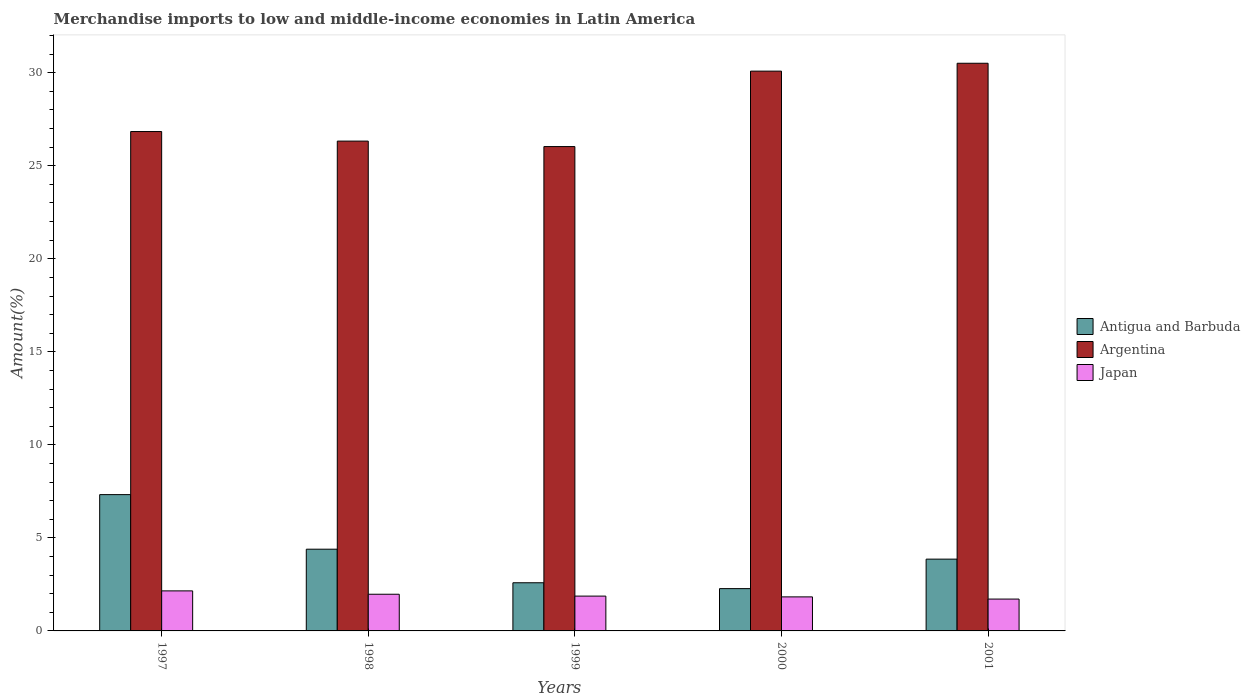How many different coloured bars are there?
Your answer should be very brief. 3. Are the number of bars per tick equal to the number of legend labels?
Offer a terse response. Yes. Are the number of bars on each tick of the X-axis equal?
Give a very brief answer. Yes. How many bars are there on the 3rd tick from the left?
Give a very brief answer. 3. How many bars are there on the 2nd tick from the right?
Provide a short and direct response. 3. What is the label of the 4th group of bars from the left?
Offer a terse response. 2000. What is the percentage of amount earned from merchandise imports in Argentina in 1997?
Provide a succinct answer. 26.84. Across all years, what is the maximum percentage of amount earned from merchandise imports in Argentina?
Offer a very short reply. 30.51. Across all years, what is the minimum percentage of amount earned from merchandise imports in Argentina?
Provide a succinct answer. 26.03. In which year was the percentage of amount earned from merchandise imports in Antigua and Barbuda maximum?
Make the answer very short. 1997. What is the total percentage of amount earned from merchandise imports in Antigua and Barbuda in the graph?
Your answer should be compact. 20.44. What is the difference between the percentage of amount earned from merchandise imports in Antigua and Barbuda in 1997 and that in 2000?
Provide a succinct answer. 5.05. What is the difference between the percentage of amount earned from merchandise imports in Argentina in 1998 and the percentage of amount earned from merchandise imports in Antigua and Barbuda in 1997?
Offer a very short reply. 19. What is the average percentage of amount earned from merchandise imports in Argentina per year?
Keep it short and to the point. 27.96. In the year 1998, what is the difference between the percentage of amount earned from merchandise imports in Argentina and percentage of amount earned from merchandise imports in Japan?
Give a very brief answer. 24.35. What is the ratio of the percentage of amount earned from merchandise imports in Antigua and Barbuda in 1999 to that in 2000?
Ensure brevity in your answer.  1.14. What is the difference between the highest and the second highest percentage of amount earned from merchandise imports in Antigua and Barbuda?
Ensure brevity in your answer.  2.93. What is the difference between the highest and the lowest percentage of amount earned from merchandise imports in Japan?
Provide a succinct answer. 0.44. In how many years, is the percentage of amount earned from merchandise imports in Antigua and Barbuda greater than the average percentage of amount earned from merchandise imports in Antigua and Barbuda taken over all years?
Offer a very short reply. 2. What does the 1st bar from the left in 1999 represents?
Offer a very short reply. Antigua and Barbuda. Is it the case that in every year, the sum of the percentage of amount earned from merchandise imports in Argentina and percentage of amount earned from merchandise imports in Antigua and Barbuda is greater than the percentage of amount earned from merchandise imports in Japan?
Your response must be concise. Yes. Are the values on the major ticks of Y-axis written in scientific E-notation?
Offer a terse response. No. Does the graph contain any zero values?
Your response must be concise. No. What is the title of the graph?
Offer a terse response. Merchandise imports to low and middle-income economies in Latin America. What is the label or title of the Y-axis?
Make the answer very short. Amount(%). What is the Amount(%) in Antigua and Barbuda in 1997?
Offer a terse response. 7.33. What is the Amount(%) of Argentina in 1997?
Your answer should be compact. 26.84. What is the Amount(%) of Japan in 1997?
Offer a very short reply. 2.15. What is the Amount(%) in Antigua and Barbuda in 1998?
Keep it short and to the point. 4.39. What is the Amount(%) in Argentina in 1998?
Keep it short and to the point. 26.32. What is the Amount(%) in Japan in 1998?
Offer a terse response. 1.97. What is the Amount(%) in Antigua and Barbuda in 1999?
Give a very brief answer. 2.59. What is the Amount(%) of Argentina in 1999?
Ensure brevity in your answer.  26.03. What is the Amount(%) of Japan in 1999?
Make the answer very short. 1.87. What is the Amount(%) in Antigua and Barbuda in 2000?
Ensure brevity in your answer.  2.27. What is the Amount(%) in Argentina in 2000?
Offer a very short reply. 30.09. What is the Amount(%) of Japan in 2000?
Give a very brief answer. 1.83. What is the Amount(%) in Antigua and Barbuda in 2001?
Provide a succinct answer. 3.86. What is the Amount(%) in Argentina in 2001?
Ensure brevity in your answer.  30.51. What is the Amount(%) of Japan in 2001?
Your answer should be compact. 1.71. Across all years, what is the maximum Amount(%) of Antigua and Barbuda?
Your response must be concise. 7.33. Across all years, what is the maximum Amount(%) in Argentina?
Your response must be concise. 30.51. Across all years, what is the maximum Amount(%) in Japan?
Make the answer very short. 2.15. Across all years, what is the minimum Amount(%) of Antigua and Barbuda?
Ensure brevity in your answer.  2.27. Across all years, what is the minimum Amount(%) of Argentina?
Provide a succinct answer. 26.03. Across all years, what is the minimum Amount(%) of Japan?
Keep it short and to the point. 1.71. What is the total Amount(%) of Antigua and Barbuda in the graph?
Make the answer very short. 20.44. What is the total Amount(%) in Argentina in the graph?
Make the answer very short. 139.79. What is the total Amount(%) of Japan in the graph?
Offer a terse response. 9.54. What is the difference between the Amount(%) in Antigua and Barbuda in 1997 and that in 1998?
Your response must be concise. 2.93. What is the difference between the Amount(%) of Argentina in 1997 and that in 1998?
Offer a terse response. 0.51. What is the difference between the Amount(%) of Japan in 1997 and that in 1998?
Provide a short and direct response. 0.18. What is the difference between the Amount(%) of Antigua and Barbuda in 1997 and that in 1999?
Provide a short and direct response. 4.74. What is the difference between the Amount(%) of Argentina in 1997 and that in 1999?
Make the answer very short. 0.81. What is the difference between the Amount(%) in Japan in 1997 and that in 1999?
Provide a short and direct response. 0.28. What is the difference between the Amount(%) in Antigua and Barbuda in 1997 and that in 2000?
Provide a succinct answer. 5.05. What is the difference between the Amount(%) of Argentina in 1997 and that in 2000?
Ensure brevity in your answer.  -3.25. What is the difference between the Amount(%) of Japan in 1997 and that in 2000?
Provide a short and direct response. 0.32. What is the difference between the Amount(%) of Antigua and Barbuda in 1997 and that in 2001?
Your answer should be very brief. 3.47. What is the difference between the Amount(%) of Argentina in 1997 and that in 2001?
Your answer should be very brief. -3.67. What is the difference between the Amount(%) of Japan in 1997 and that in 2001?
Make the answer very short. 0.44. What is the difference between the Amount(%) in Antigua and Barbuda in 1998 and that in 1999?
Your answer should be very brief. 1.8. What is the difference between the Amount(%) of Argentina in 1998 and that in 1999?
Provide a succinct answer. 0.29. What is the difference between the Amount(%) in Japan in 1998 and that in 1999?
Offer a terse response. 0.1. What is the difference between the Amount(%) of Antigua and Barbuda in 1998 and that in 2000?
Make the answer very short. 2.12. What is the difference between the Amount(%) in Argentina in 1998 and that in 2000?
Your answer should be very brief. -3.76. What is the difference between the Amount(%) of Japan in 1998 and that in 2000?
Ensure brevity in your answer.  0.14. What is the difference between the Amount(%) of Antigua and Barbuda in 1998 and that in 2001?
Give a very brief answer. 0.53. What is the difference between the Amount(%) in Argentina in 1998 and that in 2001?
Your answer should be very brief. -4.18. What is the difference between the Amount(%) in Japan in 1998 and that in 2001?
Your answer should be very brief. 0.26. What is the difference between the Amount(%) in Antigua and Barbuda in 1999 and that in 2000?
Your answer should be very brief. 0.32. What is the difference between the Amount(%) of Argentina in 1999 and that in 2000?
Offer a very short reply. -4.05. What is the difference between the Amount(%) of Japan in 1999 and that in 2000?
Keep it short and to the point. 0.04. What is the difference between the Amount(%) of Antigua and Barbuda in 1999 and that in 2001?
Keep it short and to the point. -1.27. What is the difference between the Amount(%) in Argentina in 1999 and that in 2001?
Keep it short and to the point. -4.48. What is the difference between the Amount(%) of Japan in 1999 and that in 2001?
Provide a short and direct response. 0.16. What is the difference between the Amount(%) of Antigua and Barbuda in 2000 and that in 2001?
Keep it short and to the point. -1.59. What is the difference between the Amount(%) of Argentina in 2000 and that in 2001?
Keep it short and to the point. -0.42. What is the difference between the Amount(%) in Japan in 2000 and that in 2001?
Offer a very short reply. 0.12. What is the difference between the Amount(%) of Antigua and Barbuda in 1997 and the Amount(%) of Argentina in 1998?
Your answer should be very brief. -19. What is the difference between the Amount(%) of Antigua and Barbuda in 1997 and the Amount(%) of Japan in 1998?
Your response must be concise. 5.35. What is the difference between the Amount(%) in Argentina in 1997 and the Amount(%) in Japan in 1998?
Offer a terse response. 24.87. What is the difference between the Amount(%) in Antigua and Barbuda in 1997 and the Amount(%) in Argentina in 1999?
Give a very brief answer. -18.71. What is the difference between the Amount(%) of Antigua and Barbuda in 1997 and the Amount(%) of Japan in 1999?
Ensure brevity in your answer.  5.45. What is the difference between the Amount(%) in Argentina in 1997 and the Amount(%) in Japan in 1999?
Offer a very short reply. 24.97. What is the difference between the Amount(%) in Antigua and Barbuda in 1997 and the Amount(%) in Argentina in 2000?
Your answer should be compact. -22.76. What is the difference between the Amount(%) of Antigua and Barbuda in 1997 and the Amount(%) of Japan in 2000?
Offer a terse response. 5.5. What is the difference between the Amount(%) of Argentina in 1997 and the Amount(%) of Japan in 2000?
Your answer should be compact. 25.01. What is the difference between the Amount(%) in Antigua and Barbuda in 1997 and the Amount(%) in Argentina in 2001?
Offer a terse response. -23.18. What is the difference between the Amount(%) of Antigua and Barbuda in 1997 and the Amount(%) of Japan in 2001?
Your response must be concise. 5.61. What is the difference between the Amount(%) in Argentina in 1997 and the Amount(%) in Japan in 2001?
Offer a terse response. 25.13. What is the difference between the Amount(%) of Antigua and Barbuda in 1998 and the Amount(%) of Argentina in 1999?
Keep it short and to the point. -21.64. What is the difference between the Amount(%) of Antigua and Barbuda in 1998 and the Amount(%) of Japan in 1999?
Give a very brief answer. 2.52. What is the difference between the Amount(%) of Argentina in 1998 and the Amount(%) of Japan in 1999?
Your answer should be compact. 24.45. What is the difference between the Amount(%) in Antigua and Barbuda in 1998 and the Amount(%) in Argentina in 2000?
Your response must be concise. -25.69. What is the difference between the Amount(%) in Antigua and Barbuda in 1998 and the Amount(%) in Japan in 2000?
Provide a short and direct response. 2.56. What is the difference between the Amount(%) of Argentina in 1998 and the Amount(%) of Japan in 2000?
Make the answer very short. 24.5. What is the difference between the Amount(%) of Antigua and Barbuda in 1998 and the Amount(%) of Argentina in 2001?
Keep it short and to the point. -26.12. What is the difference between the Amount(%) in Antigua and Barbuda in 1998 and the Amount(%) in Japan in 2001?
Your answer should be compact. 2.68. What is the difference between the Amount(%) of Argentina in 1998 and the Amount(%) of Japan in 2001?
Offer a very short reply. 24.61. What is the difference between the Amount(%) in Antigua and Barbuda in 1999 and the Amount(%) in Argentina in 2000?
Ensure brevity in your answer.  -27.5. What is the difference between the Amount(%) in Antigua and Barbuda in 1999 and the Amount(%) in Japan in 2000?
Provide a short and direct response. 0.76. What is the difference between the Amount(%) in Argentina in 1999 and the Amount(%) in Japan in 2000?
Provide a short and direct response. 24.2. What is the difference between the Amount(%) of Antigua and Barbuda in 1999 and the Amount(%) of Argentina in 2001?
Make the answer very short. -27.92. What is the difference between the Amount(%) of Antigua and Barbuda in 1999 and the Amount(%) of Japan in 2001?
Your answer should be very brief. 0.88. What is the difference between the Amount(%) in Argentina in 1999 and the Amount(%) in Japan in 2001?
Make the answer very short. 24.32. What is the difference between the Amount(%) in Antigua and Barbuda in 2000 and the Amount(%) in Argentina in 2001?
Your answer should be very brief. -28.24. What is the difference between the Amount(%) of Antigua and Barbuda in 2000 and the Amount(%) of Japan in 2001?
Your response must be concise. 0.56. What is the difference between the Amount(%) of Argentina in 2000 and the Amount(%) of Japan in 2001?
Ensure brevity in your answer.  28.37. What is the average Amount(%) of Antigua and Barbuda per year?
Make the answer very short. 4.09. What is the average Amount(%) of Argentina per year?
Your response must be concise. 27.96. What is the average Amount(%) of Japan per year?
Ensure brevity in your answer.  1.91. In the year 1997, what is the difference between the Amount(%) in Antigua and Barbuda and Amount(%) in Argentina?
Keep it short and to the point. -19.51. In the year 1997, what is the difference between the Amount(%) of Antigua and Barbuda and Amount(%) of Japan?
Your answer should be compact. 5.17. In the year 1997, what is the difference between the Amount(%) in Argentina and Amount(%) in Japan?
Give a very brief answer. 24.69. In the year 1998, what is the difference between the Amount(%) of Antigua and Barbuda and Amount(%) of Argentina?
Ensure brevity in your answer.  -21.93. In the year 1998, what is the difference between the Amount(%) in Antigua and Barbuda and Amount(%) in Japan?
Your response must be concise. 2.42. In the year 1998, what is the difference between the Amount(%) in Argentina and Amount(%) in Japan?
Offer a terse response. 24.35. In the year 1999, what is the difference between the Amount(%) of Antigua and Barbuda and Amount(%) of Argentina?
Your answer should be compact. -23.44. In the year 1999, what is the difference between the Amount(%) in Antigua and Barbuda and Amount(%) in Japan?
Ensure brevity in your answer.  0.72. In the year 1999, what is the difference between the Amount(%) in Argentina and Amount(%) in Japan?
Your answer should be very brief. 24.16. In the year 2000, what is the difference between the Amount(%) of Antigua and Barbuda and Amount(%) of Argentina?
Your answer should be very brief. -27.81. In the year 2000, what is the difference between the Amount(%) of Antigua and Barbuda and Amount(%) of Japan?
Provide a short and direct response. 0.44. In the year 2000, what is the difference between the Amount(%) in Argentina and Amount(%) in Japan?
Offer a very short reply. 28.26. In the year 2001, what is the difference between the Amount(%) of Antigua and Barbuda and Amount(%) of Argentina?
Your answer should be very brief. -26.65. In the year 2001, what is the difference between the Amount(%) in Antigua and Barbuda and Amount(%) in Japan?
Offer a very short reply. 2.15. In the year 2001, what is the difference between the Amount(%) of Argentina and Amount(%) of Japan?
Provide a succinct answer. 28.8. What is the ratio of the Amount(%) of Antigua and Barbuda in 1997 to that in 1998?
Provide a succinct answer. 1.67. What is the ratio of the Amount(%) in Argentina in 1997 to that in 1998?
Your answer should be compact. 1.02. What is the ratio of the Amount(%) of Japan in 1997 to that in 1998?
Ensure brevity in your answer.  1.09. What is the ratio of the Amount(%) of Antigua and Barbuda in 1997 to that in 1999?
Give a very brief answer. 2.83. What is the ratio of the Amount(%) in Argentina in 1997 to that in 1999?
Give a very brief answer. 1.03. What is the ratio of the Amount(%) in Japan in 1997 to that in 1999?
Your response must be concise. 1.15. What is the ratio of the Amount(%) in Antigua and Barbuda in 1997 to that in 2000?
Your response must be concise. 3.22. What is the ratio of the Amount(%) in Argentina in 1997 to that in 2000?
Offer a very short reply. 0.89. What is the ratio of the Amount(%) in Japan in 1997 to that in 2000?
Provide a succinct answer. 1.18. What is the ratio of the Amount(%) of Antigua and Barbuda in 1997 to that in 2001?
Keep it short and to the point. 1.9. What is the ratio of the Amount(%) of Argentina in 1997 to that in 2001?
Provide a short and direct response. 0.88. What is the ratio of the Amount(%) of Japan in 1997 to that in 2001?
Your response must be concise. 1.26. What is the ratio of the Amount(%) in Antigua and Barbuda in 1998 to that in 1999?
Your answer should be very brief. 1.7. What is the ratio of the Amount(%) in Argentina in 1998 to that in 1999?
Keep it short and to the point. 1.01. What is the ratio of the Amount(%) in Japan in 1998 to that in 1999?
Your response must be concise. 1.05. What is the ratio of the Amount(%) of Antigua and Barbuda in 1998 to that in 2000?
Offer a very short reply. 1.93. What is the ratio of the Amount(%) of Japan in 1998 to that in 2000?
Your answer should be compact. 1.08. What is the ratio of the Amount(%) of Antigua and Barbuda in 1998 to that in 2001?
Ensure brevity in your answer.  1.14. What is the ratio of the Amount(%) of Argentina in 1998 to that in 2001?
Provide a succinct answer. 0.86. What is the ratio of the Amount(%) of Japan in 1998 to that in 2001?
Make the answer very short. 1.15. What is the ratio of the Amount(%) in Antigua and Barbuda in 1999 to that in 2000?
Your response must be concise. 1.14. What is the ratio of the Amount(%) of Argentina in 1999 to that in 2000?
Give a very brief answer. 0.87. What is the ratio of the Amount(%) in Japan in 1999 to that in 2000?
Ensure brevity in your answer.  1.02. What is the ratio of the Amount(%) of Antigua and Barbuda in 1999 to that in 2001?
Your response must be concise. 0.67. What is the ratio of the Amount(%) in Argentina in 1999 to that in 2001?
Make the answer very short. 0.85. What is the ratio of the Amount(%) of Japan in 1999 to that in 2001?
Your response must be concise. 1.09. What is the ratio of the Amount(%) of Antigua and Barbuda in 2000 to that in 2001?
Your answer should be very brief. 0.59. What is the ratio of the Amount(%) in Argentina in 2000 to that in 2001?
Provide a short and direct response. 0.99. What is the ratio of the Amount(%) in Japan in 2000 to that in 2001?
Make the answer very short. 1.07. What is the difference between the highest and the second highest Amount(%) in Antigua and Barbuda?
Your answer should be compact. 2.93. What is the difference between the highest and the second highest Amount(%) in Argentina?
Offer a very short reply. 0.42. What is the difference between the highest and the second highest Amount(%) of Japan?
Provide a short and direct response. 0.18. What is the difference between the highest and the lowest Amount(%) in Antigua and Barbuda?
Your answer should be very brief. 5.05. What is the difference between the highest and the lowest Amount(%) in Argentina?
Provide a succinct answer. 4.48. What is the difference between the highest and the lowest Amount(%) of Japan?
Offer a terse response. 0.44. 